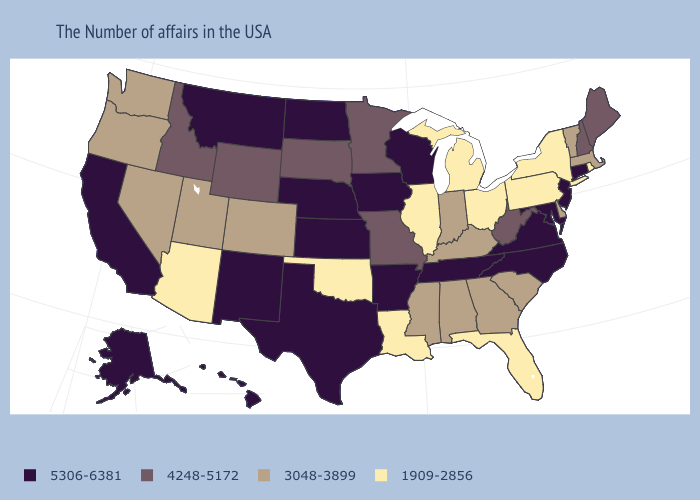Name the states that have a value in the range 3048-3899?
Give a very brief answer. Massachusetts, Vermont, Delaware, South Carolina, Georgia, Kentucky, Indiana, Alabama, Mississippi, Colorado, Utah, Nevada, Washington, Oregon. Name the states that have a value in the range 4248-5172?
Quick response, please. Maine, New Hampshire, West Virginia, Missouri, Minnesota, South Dakota, Wyoming, Idaho. Among the states that border Oregon , which have the lowest value?
Keep it brief. Nevada, Washington. Among the states that border Nevada , which have the lowest value?
Quick response, please. Arizona. Which states have the lowest value in the USA?
Give a very brief answer. Rhode Island, New York, Pennsylvania, Ohio, Florida, Michigan, Illinois, Louisiana, Oklahoma, Arizona. What is the value of Iowa?
Short answer required. 5306-6381. Does Arizona have the lowest value in the West?
Short answer required. Yes. How many symbols are there in the legend?
Answer briefly. 4. What is the value of Colorado?
Write a very short answer. 3048-3899. Does Hawaii have the highest value in the West?
Answer briefly. Yes. What is the highest value in states that border Utah?
Answer briefly. 5306-6381. Does Louisiana have the lowest value in the USA?
Short answer required. Yes. Name the states that have a value in the range 1909-2856?
Concise answer only. Rhode Island, New York, Pennsylvania, Ohio, Florida, Michigan, Illinois, Louisiana, Oklahoma, Arizona. Does California have the lowest value in the USA?
Keep it brief. No. Does the first symbol in the legend represent the smallest category?
Be succinct. No. 